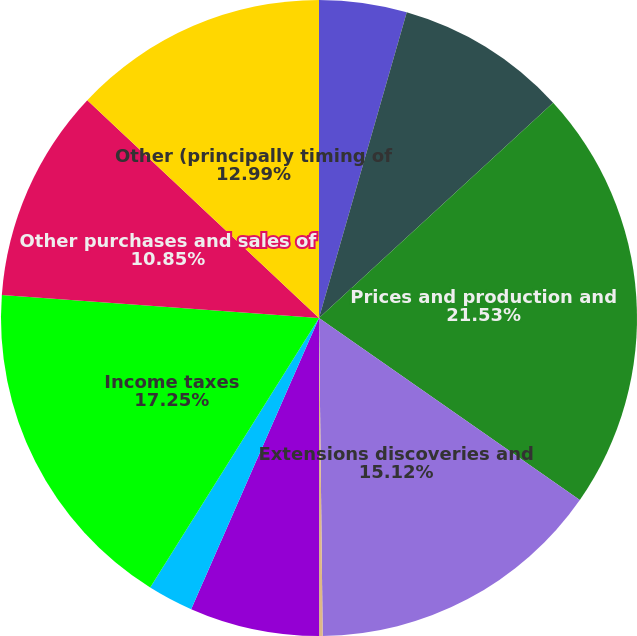Convert chart. <chart><loc_0><loc_0><loc_500><loc_500><pie_chart><fcel>Standardized measure of<fcel>Sales and transfers of gas and<fcel>Prices and production and<fcel>Extensions discoveries and<fcel>Previously estimated<fcel>Revisions of previous quantity<fcel>Accretion of discount<fcel>Income taxes<fcel>Other purchases and sales of<fcel>Other (principally timing of<nl><fcel>4.45%<fcel>8.72%<fcel>21.52%<fcel>15.12%<fcel>0.18%<fcel>6.59%<fcel>2.32%<fcel>17.25%<fcel>10.85%<fcel>12.99%<nl></chart> 